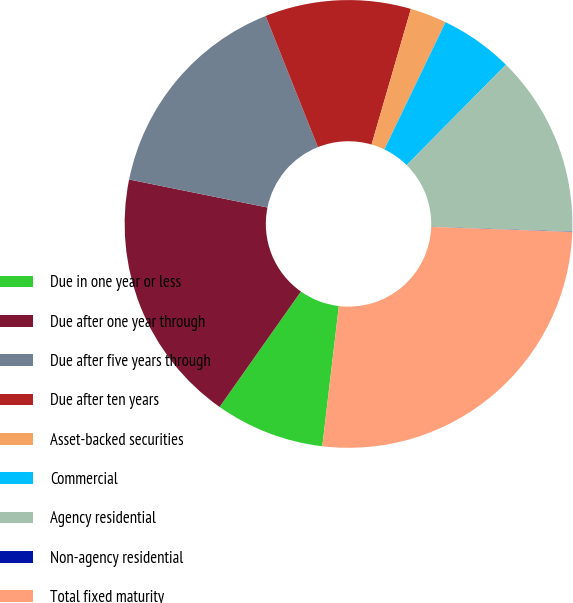Convert chart. <chart><loc_0><loc_0><loc_500><loc_500><pie_chart><fcel>Due in one year or less<fcel>Due after one year through<fcel>Due after five years through<fcel>Due after ten years<fcel>Asset-backed securities<fcel>Commercial<fcel>Agency residential<fcel>Non-agency residential<fcel>Total fixed maturity<nl><fcel>7.9%<fcel>18.41%<fcel>15.78%<fcel>10.53%<fcel>2.64%<fcel>5.27%<fcel>13.15%<fcel>0.02%<fcel>26.29%<nl></chart> 